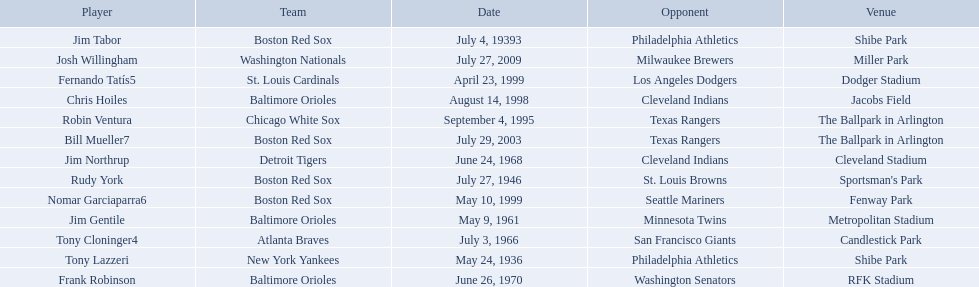Who were all of the players? Tony Lazzeri, Jim Tabor, Rudy York, Jim Gentile, Tony Cloninger4, Jim Northrup, Frank Robinson, Robin Ventura, Chris Hoiles, Fernando Tatís5, Nomar Garciaparra6, Bill Mueller7, Josh Willingham. Would you mind parsing the complete table? {'header': ['Player', 'Team', 'Date', 'Opponent', 'Venue'], 'rows': [['Jim Tabor', 'Boston Red Sox', 'July 4, 19393', 'Philadelphia Athletics', 'Shibe Park'], ['Josh Willingham', 'Washington Nationals', 'July 27, 2009', 'Milwaukee Brewers', 'Miller Park'], ['Fernando Tatís5', 'St. Louis Cardinals', 'April 23, 1999', 'Los Angeles Dodgers', 'Dodger Stadium'], ['Chris Hoiles', 'Baltimore Orioles', 'August 14, 1998', 'Cleveland Indians', 'Jacobs Field'], ['Robin Ventura', 'Chicago White Sox', 'September 4, 1995', 'Texas Rangers', 'The Ballpark in Arlington'], ['Bill Mueller7', 'Boston Red Sox', 'July 29, 2003', 'Texas Rangers', 'The Ballpark in Arlington'], ['Jim Northrup', 'Detroit Tigers', 'June 24, 1968', 'Cleveland Indians', 'Cleveland Stadium'], ['Rudy York', 'Boston Red Sox', 'July 27, 1946', 'St. Louis Browns', "Sportsman's Park"], ['Nomar Garciaparra6', 'Boston Red Sox', 'May 10, 1999', 'Seattle Mariners', 'Fenway Park'], ['Jim Gentile', 'Baltimore Orioles', 'May 9, 1961', 'Minnesota Twins', 'Metropolitan Stadium'], ['Tony Cloninger4', 'Atlanta Braves', 'July 3, 1966', 'San Francisco Giants', 'Candlestick Park'], ['Tony Lazzeri', 'New York Yankees', 'May 24, 1936', 'Philadelphia Athletics', 'Shibe Park'], ['Frank Robinson', 'Baltimore Orioles', 'June 26, 1970', 'Washington Senators', 'RFK Stadium']]} What year was there a player for the yankees? May 24, 1936. What was the name of that 1936 yankees player? Tony Lazzeri. What were the dates of each game? May 24, 1936, July 4, 19393, July 27, 1946, May 9, 1961, July 3, 1966, June 24, 1968, June 26, 1970, September 4, 1995, August 14, 1998, April 23, 1999, May 10, 1999, July 29, 2003, July 27, 2009. Who were all of the teams? New York Yankees, Boston Red Sox, Boston Red Sox, Baltimore Orioles, Atlanta Braves, Detroit Tigers, Baltimore Orioles, Chicago White Sox, Baltimore Orioles, St. Louis Cardinals, Boston Red Sox, Boston Red Sox, Washington Nationals. What about their opponents? Philadelphia Athletics, Philadelphia Athletics, St. Louis Browns, Minnesota Twins, San Francisco Giants, Cleveland Indians, Washington Senators, Texas Rangers, Cleveland Indians, Los Angeles Dodgers, Seattle Mariners, Texas Rangers, Milwaukee Brewers. Can you give me this table in json format? {'header': ['Player', 'Team', 'Date', 'Opponent', 'Venue'], 'rows': [['Jim Tabor', 'Boston Red Sox', 'July 4, 19393', 'Philadelphia Athletics', 'Shibe Park'], ['Josh Willingham', 'Washington Nationals', 'July 27, 2009', 'Milwaukee Brewers', 'Miller Park'], ['Fernando Tatís5', 'St. Louis Cardinals', 'April 23, 1999', 'Los Angeles Dodgers', 'Dodger Stadium'], ['Chris Hoiles', 'Baltimore Orioles', 'August 14, 1998', 'Cleveland Indians', 'Jacobs Field'], ['Robin Ventura', 'Chicago White Sox', 'September 4, 1995', 'Texas Rangers', 'The Ballpark in Arlington'], ['Bill Mueller7', 'Boston Red Sox', 'July 29, 2003', 'Texas Rangers', 'The Ballpark in Arlington'], ['Jim Northrup', 'Detroit Tigers', 'June 24, 1968', 'Cleveland Indians', 'Cleveland Stadium'], ['Rudy York', 'Boston Red Sox', 'July 27, 1946', 'St. Louis Browns', "Sportsman's Park"], ['Nomar Garciaparra6', 'Boston Red Sox', 'May 10, 1999', 'Seattle Mariners', 'Fenway Park'], ['Jim Gentile', 'Baltimore Orioles', 'May 9, 1961', 'Minnesota Twins', 'Metropolitan Stadium'], ['Tony Cloninger4', 'Atlanta Braves', 'July 3, 1966', 'San Francisco Giants', 'Candlestick Park'], ['Tony Lazzeri', 'New York Yankees', 'May 24, 1936', 'Philadelphia Athletics', 'Shibe Park'], ['Frank Robinson', 'Baltimore Orioles', 'June 26, 1970', 'Washington Senators', 'RFK Stadium']]} And on which date did the detroit tigers play against the cleveland indians? June 24, 1968. 